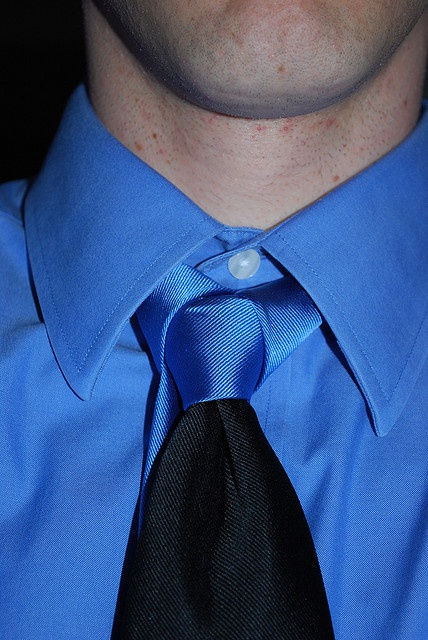Describe the objects in this image and their specific colors. I can see people in blue, black, and gray tones and tie in black, navy, darkblue, and lightblue tones in this image. 